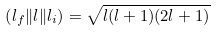Convert formula to latex. <formula><loc_0><loc_0><loc_500><loc_500>\left ( l _ { f } \| { l } \| l _ { i } \right ) = \sqrt { l ( l + 1 ) ( 2 l + 1 ) }</formula> 